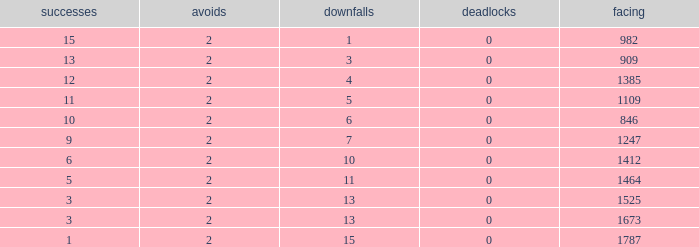What is the number listed under against when there were less than 13 losses and less than 2 byes? 0.0. 